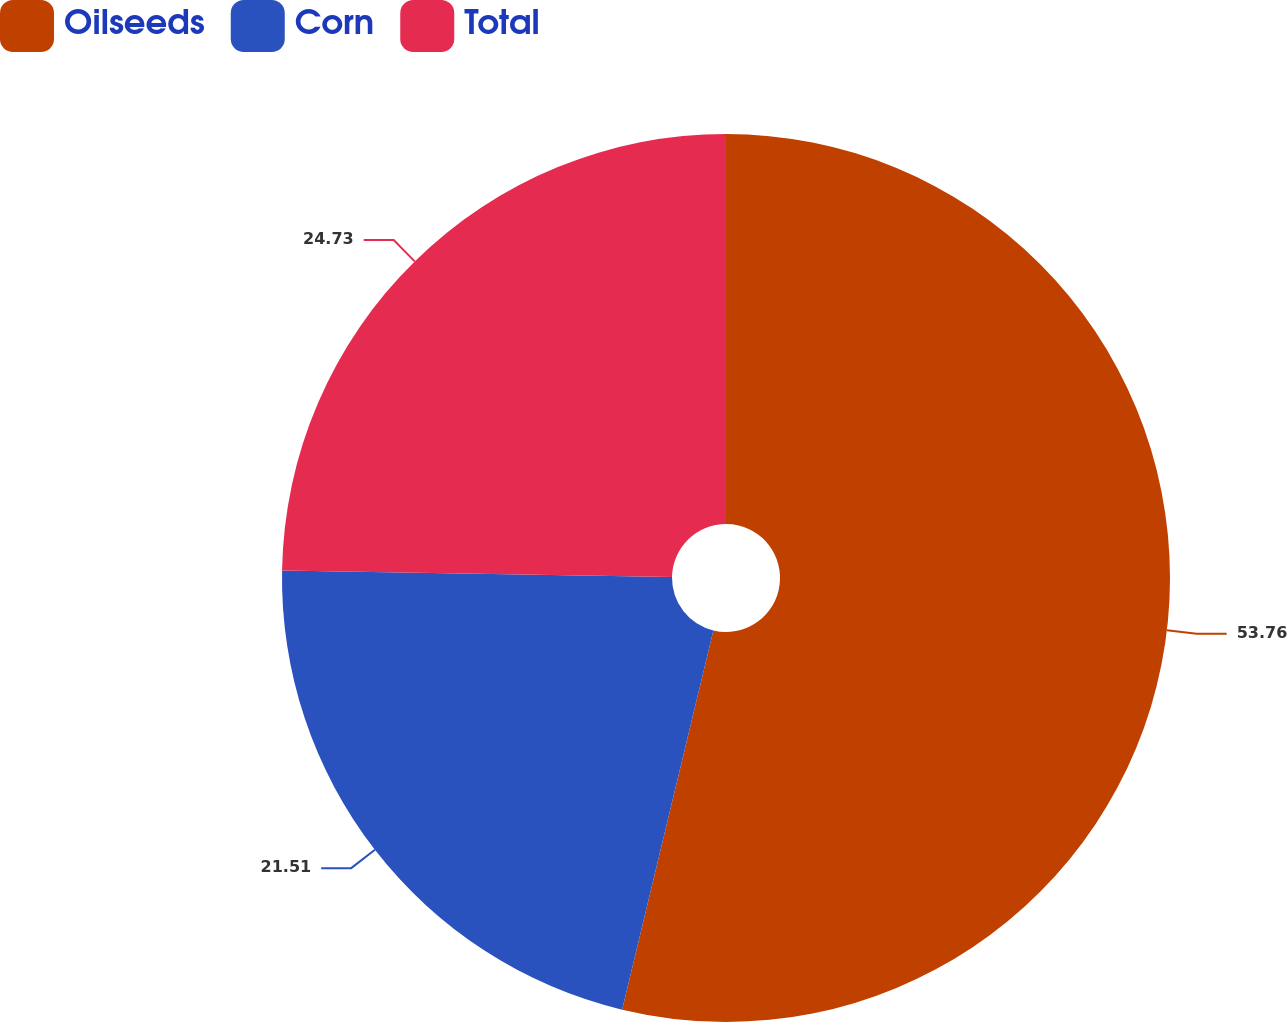Convert chart. <chart><loc_0><loc_0><loc_500><loc_500><pie_chart><fcel>Oilseeds<fcel>Corn<fcel>Total<nl><fcel>53.76%<fcel>21.51%<fcel>24.73%<nl></chart> 